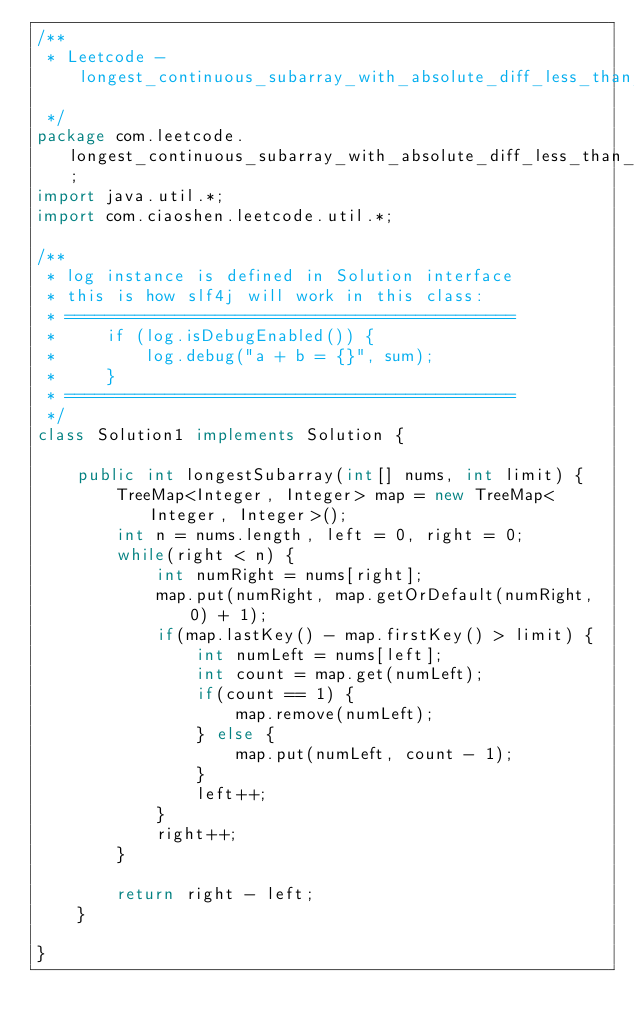<code> <loc_0><loc_0><loc_500><loc_500><_Java_>/**
 * Leetcode - longest_continuous_subarray_with_absolute_diff_less_than_or_equal_to_limit
 */
package com.leetcode.longest_continuous_subarray_with_absolute_diff_less_than_or_equal_to_limit;
import java.util.*;
import com.ciaoshen.leetcode.util.*;

/** 
 * log instance is defined in Solution interface
 * this is how slf4j will work in this class:
 * =============================================
 *     if (log.isDebugEnabled()) {
 *         log.debug("a + b = {}", sum);
 *     }
 * =============================================
 */
class Solution1 implements Solution {

    public int longestSubarray(int[] nums, int limit) {
        TreeMap<Integer, Integer> map = new TreeMap<Integer, Integer>();
        int n = nums.length, left = 0, right = 0;
        while(right < n) {
            int numRight = nums[right];
            map.put(numRight, map.getOrDefault(numRight, 0) + 1);
            if(map.lastKey() - map.firstKey() > limit) {
                int numLeft = nums[left];
                int count = map.get(numLeft);
                if(count == 1) {
                    map.remove(numLeft);
                } else {
                    map.put(numLeft, count - 1);
                }
                left++;
            }
            right++;
        }

        return right - left;
    }

}
</code> 